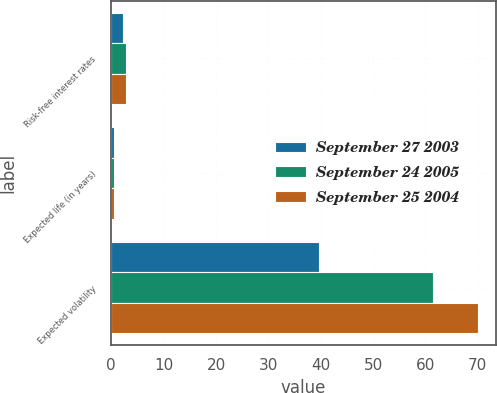Convert chart to OTSL. <chart><loc_0><loc_0><loc_500><loc_500><stacked_bar_chart><ecel><fcel>Risk-free interest rates<fcel>Expected life (in years)<fcel>Expected volatility<nl><fcel>September 27 2003<fcel>2.3<fcel>0.5<fcel>39.7<nl><fcel>September 24 2005<fcel>2.8<fcel>0.5<fcel>61.4<nl><fcel>September 25 2004<fcel>2.9<fcel>0.5<fcel>70<nl></chart> 